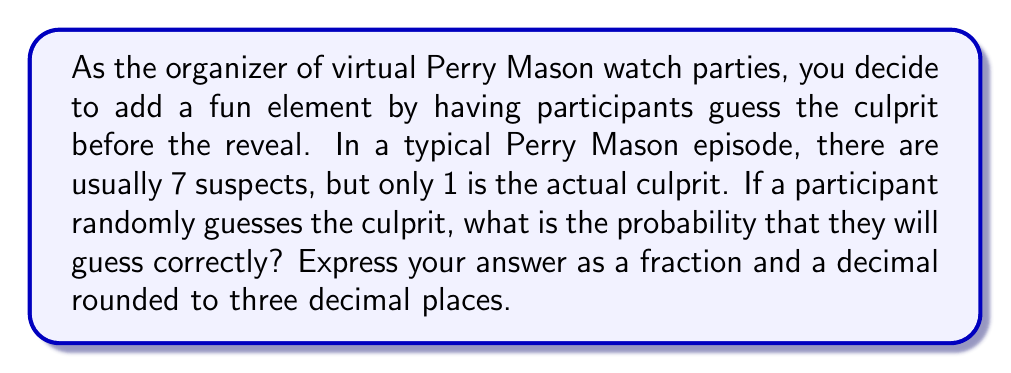Give your solution to this math problem. To solve this problem, we need to use the concept of probability for a single event occurring out of a set of equally likely outcomes.

1) In this case, there are 7 suspects in total, and only 1 of them is the actual culprit.

2) The probability of a correct guess is calculated by dividing the number of favorable outcomes by the total number of possible outcomes:

   $$P(\text{correct guess}) = \frac{\text{number of favorable outcomes}}{\text{total number of possible outcomes}}$$

3) Here, there is only 1 favorable outcome (guessing the correct culprit) out of 7 possible outcomes (the total number of suspects):

   $$P(\text{correct guess}) = \frac{1}{7}$$

4) To express this as a decimal, we divide 1 by 7:

   $$\frac{1}{7} \approx 0.142857...$$

5) Rounding to three decimal places:

   $$0.142857... \approx 0.143$$

Therefore, the probability of correctly guessing the culprit is $\frac{1}{7}$ or approximately 0.143.
Answer: $\frac{1}{7}$ or 0.143 